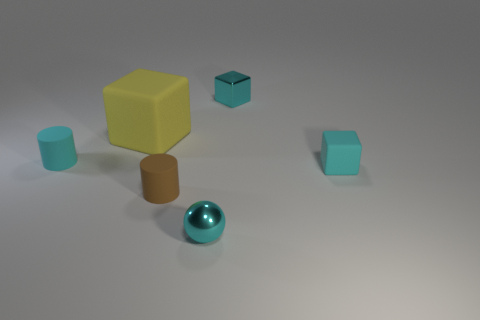Subtract all yellow blocks. How many blocks are left? 2 Subtract all cyan cylinders. How many cylinders are left? 1 Subtract all cylinders. How many objects are left? 4 Add 1 matte things. How many matte things are left? 5 Add 5 large red objects. How many large red objects exist? 5 Add 3 small brown rubber cylinders. How many objects exist? 9 Subtract 0 blue balls. How many objects are left? 6 Subtract 1 cylinders. How many cylinders are left? 1 Subtract all purple blocks. Subtract all brown cylinders. How many blocks are left? 3 Subtract all purple cylinders. How many cyan blocks are left? 2 